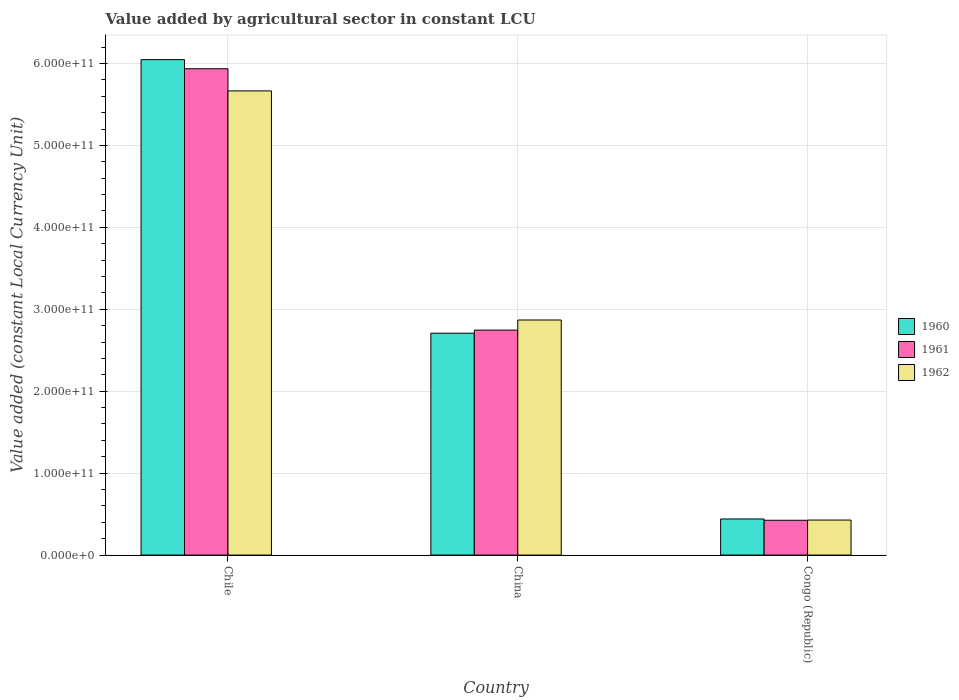How many different coloured bars are there?
Provide a succinct answer. 3. How many groups of bars are there?
Your answer should be compact. 3. Are the number of bars per tick equal to the number of legend labels?
Offer a terse response. Yes. In how many cases, is the number of bars for a given country not equal to the number of legend labels?
Your response must be concise. 0. What is the value added by agricultural sector in 1961 in Chile?
Your answer should be very brief. 5.94e+11. Across all countries, what is the maximum value added by agricultural sector in 1961?
Offer a terse response. 5.94e+11. Across all countries, what is the minimum value added by agricultural sector in 1962?
Give a very brief answer. 4.27e+1. In which country was the value added by agricultural sector in 1962 maximum?
Your answer should be very brief. Chile. In which country was the value added by agricultural sector in 1962 minimum?
Offer a terse response. Congo (Republic). What is the total value added by agricultural sector in 1961 in the graph?
Offer a very short reply. 9.11e+11. What is the difference between the value added by agricultural sector in 1962 in Chile and that in China?
Your answer should be very brief. 2.80e+11. What is the difference between the value added by agricultural sector in 1960 in China and the value added by agricultural sector in 1962 in Congo (Republic)?
Make the answer very short. 2.28e+11. What is the average value added by agricultural sector in 1960 per country?
Ensure brevity in your answer.  3.07e+11. What is the difference between the value added by agricultural sector of/in 1961 and value added by agricultural sector of/in 1960 in China?
Give a very brief answer. 3.79e+09. In how many countries, is the value added by agricultural sector in 1960 greater than 360000000000 LCU?
Your answer should be compact. 1. What is the ratio of the value added by agricultural sector in 1960 in Chile to that in Congo (Republic)?
Ensure brevity in your answer.  13.73. What is the difference between the highest and the second highest value added by agricultural sector in 1961?
Your answer should be very brief. 5.51e+11. What is the difference between the highest and the lowest value added by agricultural sector in 1960?
Provide a short and direct response. 5.61e+11. Is the sum of the value added by agricultural sector in 1961 in Chile and Congo (Republic) greater than the maximum value added by agricultural sector in 1960 across all countries?
Offer a terse response. Yes. What does the 2nd bar from the left in Chile represents?
Offer a terse response. 1961. What does the 2nd bar from the right in China represents?
Your answer should be very brief. 1961. How many bars are there?
Give a very brief answer. 9. How many countries are there in the graph?
Offer a terse response. 3. What is the difference between two consecutive major ticks on the Y-axis?
Provide a succinct answer. 1.00e+11. Does the graph contain any zero values?
Make the answer very short. No. Does the graph contain grids?
Make the answer very short. Yes. How many legend labels are there?
Your answer should be very brief. 3. How are the legend labels stacked?
Your response must be concise. Vertical. What is the title of the graph?
Offer a terse response. Value added by agricultural sector in constant LCU. Does "1982" appear as one of the legend labels in the graph?
Provide a succinct answer. No. What is the label or title of the Y-axis?
Your response must be concise. Value added (constant Local Currency Unit). What is the Value added (constant Local Currency Unit) in 1960 in Chile?
Make the answer very short. 6.05e+11. What is the Value added (constant Local Currency Unit) of 1961 in Chile?
Your answer should be compact. 5.94e+11. What is the Value added (constant Local Currency Unit) in 1962 in Chile?
Ensure brevity in your answer.  5.67e+11. What is the Value added (constant Local Currency Unit) in 1960 in China?
Give a very brief answer. 2.71e+11. What is the Value added (constant Local Currency Unit) of 1961 in China?
Give a very brief answer. 2.75e+11. What is the Value added (constant Local Currency Unit) of 1962 in China?
Ensure brevity in your answer.  2.87e+11. What is the Value added (constant Local Currency Unit) of 1960 in Congo (Republic)?
Keep it short and to the point. 4.41e+1. What is the Value added (constant Local Currency Unit) in 1961 in Congo (Republic)?
Keep it short and to the point. 4.25e+1. What is the Value added (constant Local Currency Unit) in 1962 in Congo (Republic)?
Your response must be concise. 4.27e+1. Across all countries, what is the maximum Value added (constant Local Currency Unit) in 1960?
Offer a terse response. 6.05e+11. Across all countries, what is the maximum Value added (constant Local Currency Unit) of 1961?
Your answer should be very brief. 5.94e+11. Across all countries, what is the maximum Value added (constant Local Currency Unit) in 1962?
Offer a very short reply. 5.67e+11. Across all countries, what is the minimum Value added (constant Local Currency Unit) of 1960?
Offer a terse response. 4.41e+1. Across all countries, what is the minimum Value added (constant Local Currency Unit) of 1961?
Provide a short and direct response. 4.25e+1. Across all countries, what is the minimum Value added (constant Local Currency Unit) in 1962?
Your answer should be very brief. 4.27e+1. What is the total Value added (constant Local Currency Unit) in 1960 in the graph?
Provide a succinct answer. 9.20e+11. What is the total Value added (constant Local Currency Unit) in 1961 in the graph?
Offer a terse response. 9.11e+11. What is the total Value added (constant Local Currency Unit) in 1962 in the graph?
Offer a very short reply. 8.96e+11. What is the difference between the Value added (constant Local Currency Unit) in 1960 in Chile and that in China?
Give a very brief answer. 3.34e+11. What is the difference between the Value added (constant Local Currency Unit) of 1961 in Chile and that in China?
Give a very brief answer. 3.19e+11. What is the difference between the Value added (constant Local Currency Unit) in 1962 in Chile and that in China?
Your answer should be very brief. 2.80e+11. What is the difference between the Value added (constant Local Currency Unit) of 1960 in Chile and that in Congo (Republic)?
Make the answer very short. 5.61e+11. What is the difference between the Value added (constant Local Currency Unit) in 1961 in Chile and that in Congo (Republic)?
Provide a succinct answer. 5.51e+11. What is the difference between the Value added (constant Local Currency Unit) of 1962 in Chile and that in Congo (Republic)?
Provide a succinct answer. 5.24e+11. What is the difference between the Value added (constant Local Currency Unit) in 1960 in China and that in Congo (Republic)?
Make the answer very short. 2.27e+11. What is the difference between the Value added (constant Local Currency Unit) of 1961 in China and that in Congo (Republic)?
Ensure brevity in your answer.  2.32e+11. What is the difference between the Value added (constant Local Currency Unit) in 1962 in China and that in Congo (Republic)?
Offer a very short reply. 2.44e+11. What is the difference between the Value added (constant Local Currency Unit) of 1960 in Chile and the Value added (constant Local Currency Unit) of 1961 in China?
Keep it short and to the point. 3.30e+11. What is the difference between the Value added (constant Local Currency Unit) of 1960 in Chile and the Value added (constant Local Currency Unit) of 1962 in China?
Make the answer very short. 3.18e+11. What is the difference between the Value added (constant Local Currency Unit) in 1961 in Chile and the Value added (constant Local Currency Unit) in 1962 in China?
Offer a very short reply. 3.07e+11. What is the difference between the Value added (constant Local Currency Unit) of 1960 in Chile and the Value added (constant Local Currency Unit) of 1961 in Congo (Republic)?
Your response must be concise. 5.62e+11. What is the difference between the Value added (constant Local Currency Unit) of 1960 in Chile and the Value added (constant Local Currency Unit) of 1962 in Congo (Republic)?
Make the answer very short. 5.62e+11. What is the difference between the Value added (constant Local Currency Unit) of 1961 in Chile and the Value added (constant Local Currency Unit) of 1962 in Congo (Republic)?
Ensure brevity in your answer.  5.51e+11. What is the difference between the Value added (constant Local Currency Unit) in 1960 in China and the Value added (constant Local Currency Unit) in 1961 in Congo (Republic)?
Keep it short and to the point. 2.28e+11. What is the difference between the Value added (constant Local Currency Unit) in 1960 in China and the Value added (constant Local Currency Unit) in 1962 in Congo (Republic)?
Ensure brevity in your answer.  2.28e+11. What is the difference between the Value added (constant Local Currency Unit) of 1961 in China and the Value added (constant Local Currency Unit) of 1962 in Congo (Republic)?
Provide a short and direct response. 2.32e+11. What is the average Value added (constant Local Currency Unit) in 1960 per country?
Provide a succinct answer. 3.07e+11. What is the average Value added (constant Local Currency Unit) in 1961 per country?
Offer a very short reply. 3.04e+11. What is the average Value added (constant Local Currency Unit) of 1962 per country?
Offer a very short reply. 2.99e+11. What is the difference between the Value added (constant Local Currency Unit) in 1960 and Value added (constant Local Currency Unit) in 1961 in Chile?
Your response must be concise. 1.11e+1. What is the difference between the Value added (constant Local Currency Unit) in 1960 and Value added (constant Local Currency Unit) in 1962 in Chile?
Provide a succinct answer. 3.82e+1. What is the difference between the Value added (constant Local Currency Unit) in 1961 and Value added (constant Local Currency Unit) in 1962 in Chile?
Offer a very short reply. 2.70e+1. What is the difference between the Value added (constant Local Currency Unit) of 1960 and Value added (constant Local Currency Unit) of 1961 in China?
Provide a succinct answer. -3.79e+09. What is the difference between the Value added (constant Local Currency Unit) of 1960 and Value added (constant Local Currency Unit) of 1962 in China?
Make the answer very short. -1.61e+1. What is the difference between the Value added (constant Local Currency Unit) of 1961 and Value added (constant Local Currency Unit) of 1962 in China?
Offer a terse response. -1.24e+1. What is the difference between the Value added (constant Local Currency Unit) of 1960 and Value added (constant Local Currency Unit) of 1961 in Congo (Republic)?
Ensure brevity in your answer.  1.57e+09. What is the difference between the Value added (constant Local Currency Unit) in 1960 and Value added (constant Local Currency Unit) in 1962 in Congo (Republic)?
Your answer should be very brief. 1.32e+09. What is the difference between the Value added (constant Local Currency Unit) in 1961 and Value added (constant Local Currency Unit) in 1962 in Congo (Republic)?
Your response must be concise. -2.56e+08. What is the ratio of the Value added (constant Local Currency Unit) in 1960 in Chile to that in China?
Keep it short and to the point. 2.23. What is the ratio of the Value added (constant Local Currency Unit) in 1961 in Chile to that in China?
Offer a terse response. 2.16. What is the ratio of the Value added (constant Local Currency Unit) of 1962 in Chile to that in China?
Ensure brevity in your answer.  1.97. What is the ratio of the Value added (constant Local Currency Unit) of 1960 in Chile to that in Congo (Republic)?
Offer a very short reply. 13.73. What is the ratio of the Value added (constant Local Currency Unit) in 1961 in Chile to that in Congo (Republic)?
Your response must be concise. 13.97. What is the ratio of the Value added (constant Local Currency Unit) in 1962 in Chile to that in Congo (Republic)?
Make the answer very short. 13.26. What is the ratio of the Value added (constant Local Currency Unit) in 1960 in China to that in Congo (Republic)?
Provide a succinct answer. 6.15. What is the ratio of the Value added (constant Local Currency Unit) in 1961 in China to that in Congo (Republic)?
Your answer should be very brief. 6.46. What is the ratio of the Value added (constant Local Currency Unit) in 1962 in China to that in Congo (Republic)?
Make the answer very short. 6.71. What is the difference between the highest and the second highest Value added (constant Local Currency Unit) in 1960?
Offer a terse response. 3.34e+11. What is the difference between the highest and the second highest Value added (constant Local Currency Unit) of 1961?
Make the answer very short. 3.19e+11. What is the difference between the highest and the second highest Value added (constant Local Currency Unit) in 1962?
Keep it short and to the point. 2.80e+11. What is the difference between the highest and the lowest Value added (constant Local Currency Unit) in 1960?
Your response must be concise. 5.61e+11. What is the difference between the highest and the lowest Value added (constant Local Currency Unit) in 1961?
Offer a very short reply. 5.51e+11. What is the difference between the highest and the lowest Value added (constant Local Currency Unit) of 1962?
Ensure brevity in your answer.  5.24e+11. 